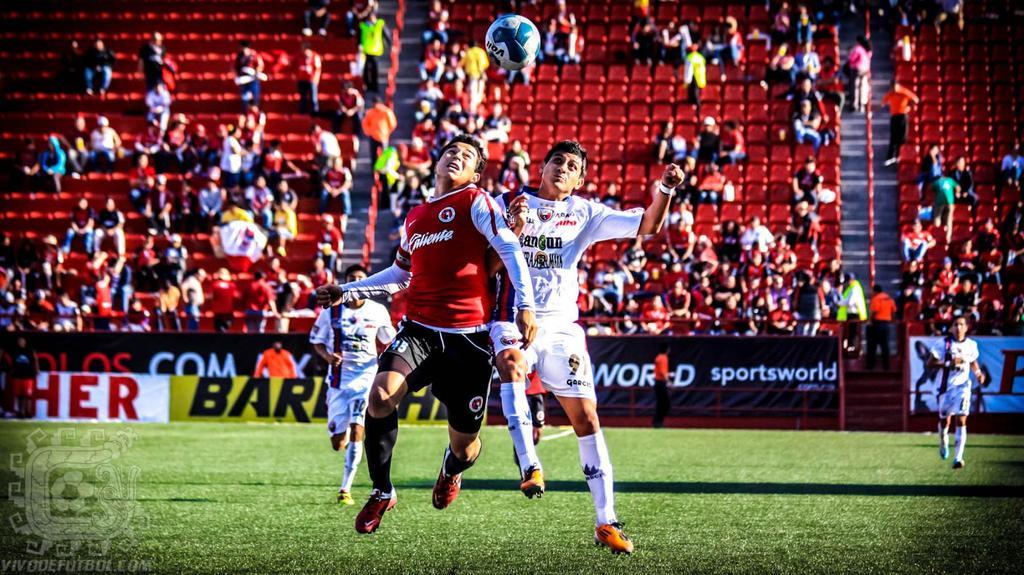What brands are advertising at this game?
Offer a very short reply. Sportsworld. 